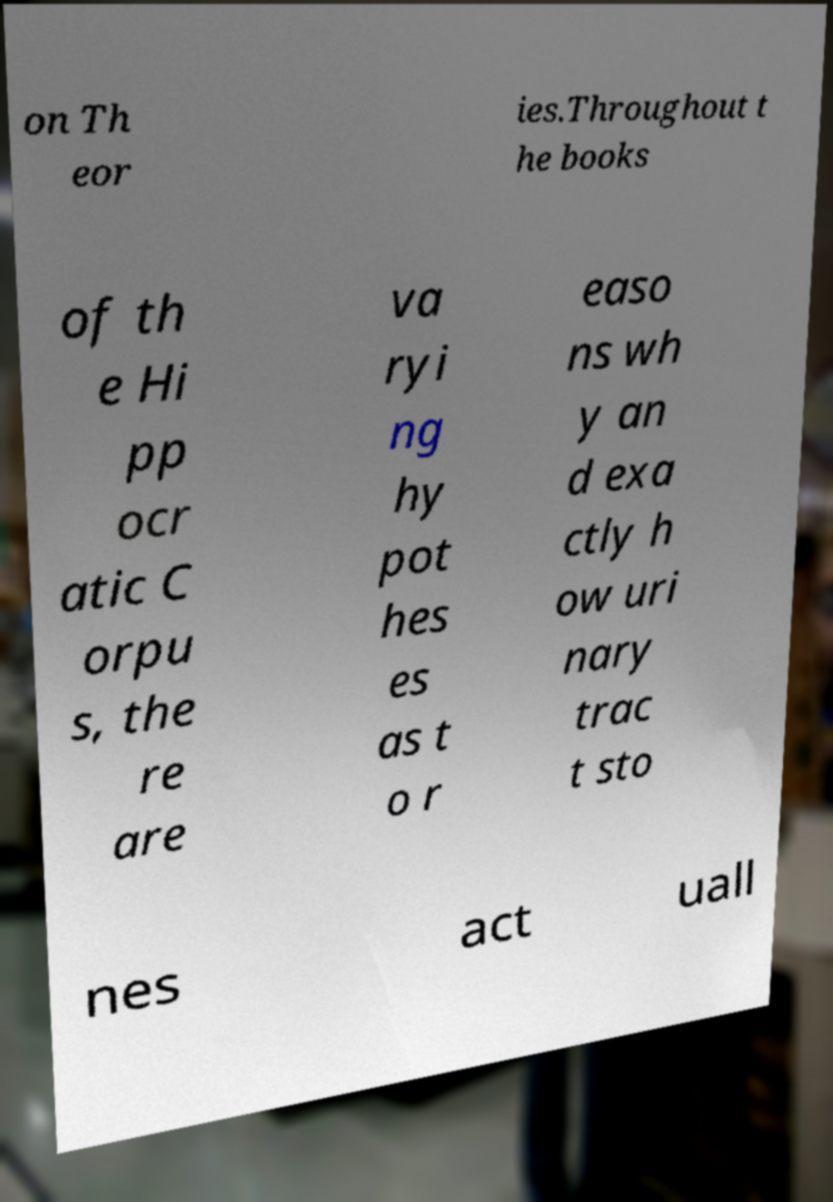Could you assist in decoding the text presented in this image and type it out clearly? on Th eor ies.Throughout t he books of th e Hi pp ocr atic C orpu s, the re are va ryi ng hy pot hes es as t o r easo ns wh y an d exa ctly h ow uri nary trac t sto nes act uall 